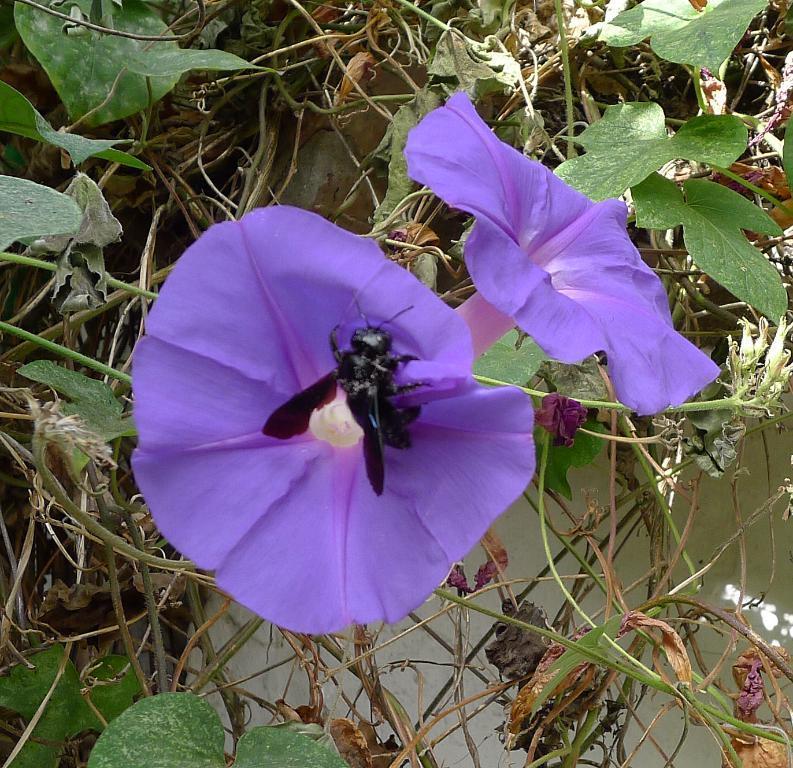In one or two sentences, can you explain what this image depicts? In this image there are plants and flowers. In the background of the image there is a wall. 